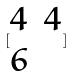Convert formula to latex. <formula><loc_0><loc_0><loc_500><loc_500>[ \begin{matrix} 4 & 4 \\ 6 \end{matrix} ]</formula> 